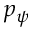<formula> <loc_0><loc_0><loc_500><loc_500>p _ { \psi }</formula> 